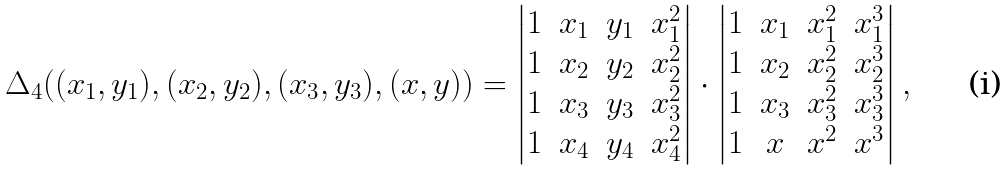Convert formula to latex. <formula><loc_0><loc_0><loc_500><loc_500>\Delta _ { 4 } ( ( x _ { 1 } , y _ { 1 } ) , ( x _ { 2 } , y _ { 2 } ) , ( x _ { 3 } , y _ { 3 } ) , ( x , y ) ) = \left | \begin{matrix} 1 & x _ { 1 } & y _ { 1 } & x _ { 1 } ^ { 2 } \\ 1 & x _ { 2 } & y _ { 2 } & x _ { 2 } ^ { 2 } \\ 1 & x _ { 3 } & y _ { 3 } & x _ { 3 } ^ { 2 } \\ 1 & x _ { 4 } & y _ { 4 } & x _ { 4 } ^ { 2 } \\ \end{matrix} \right | \cdot \left | \begin{matrix} 1 & x _ { 1 } & x _ { 1 } ^ { 2 } & x _ { 1 } ^ { 3 } \\ 1 & x _ { 2 } & x _ { 2 } ^ { 2 } & x _ { 2 } ^ { 3 } \\ 1 & x _ { 3 } & x _ { 3 } ^ { 2 } & x _ { 3 } ^ { 3 } \\ 1 & x & x ^ { 2 } & x ^ { 3 } \\ \end{matrix} \right | ,</formula> 